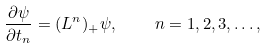<formula> <loc_0><loc_0><loc_500><loc_500>\frac { \partial \psi } { \partial t _ { n } } = ( L ^ { n } ) _ { + } \psi , \quad n = 1 , 2 , 3 , \dots ,</formula> 